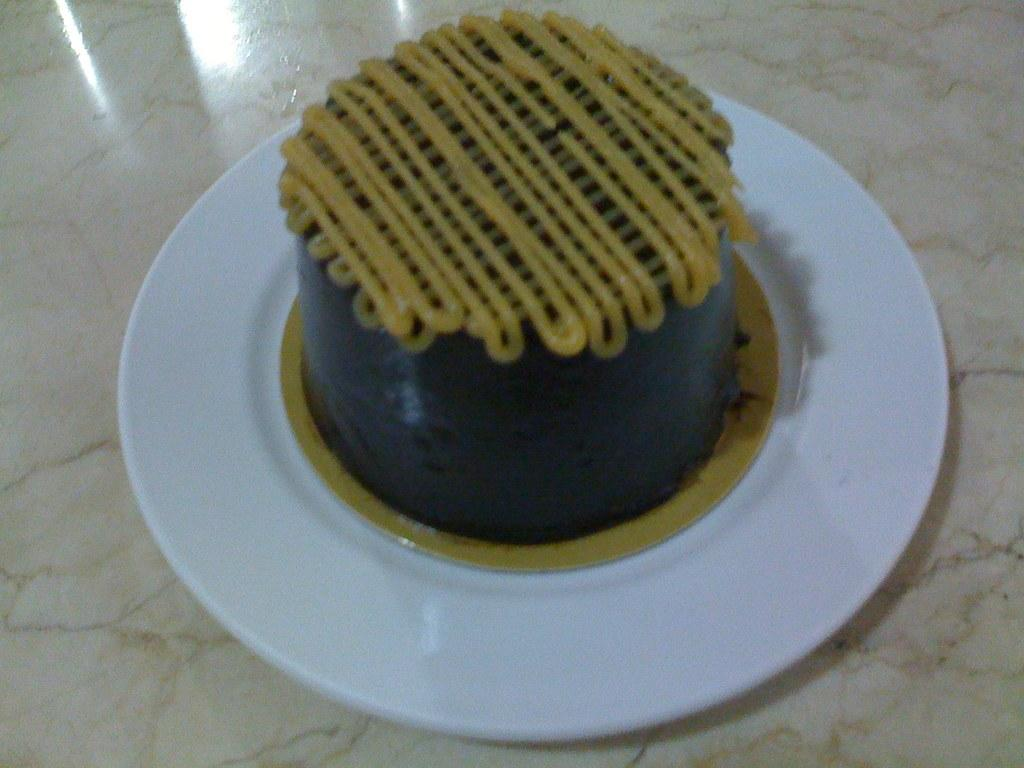What is the main subject of the image? There is a cake in the image. How is the cake presented? The cake is on a white plate. What is the plate resting on? The plate is on an object. How many earthquakes can be seen happening in the image? There are no earthquakes present in the image. What is the amount of cake on the plate? The amount of cake on the plate cannot be determined from the image alone. 